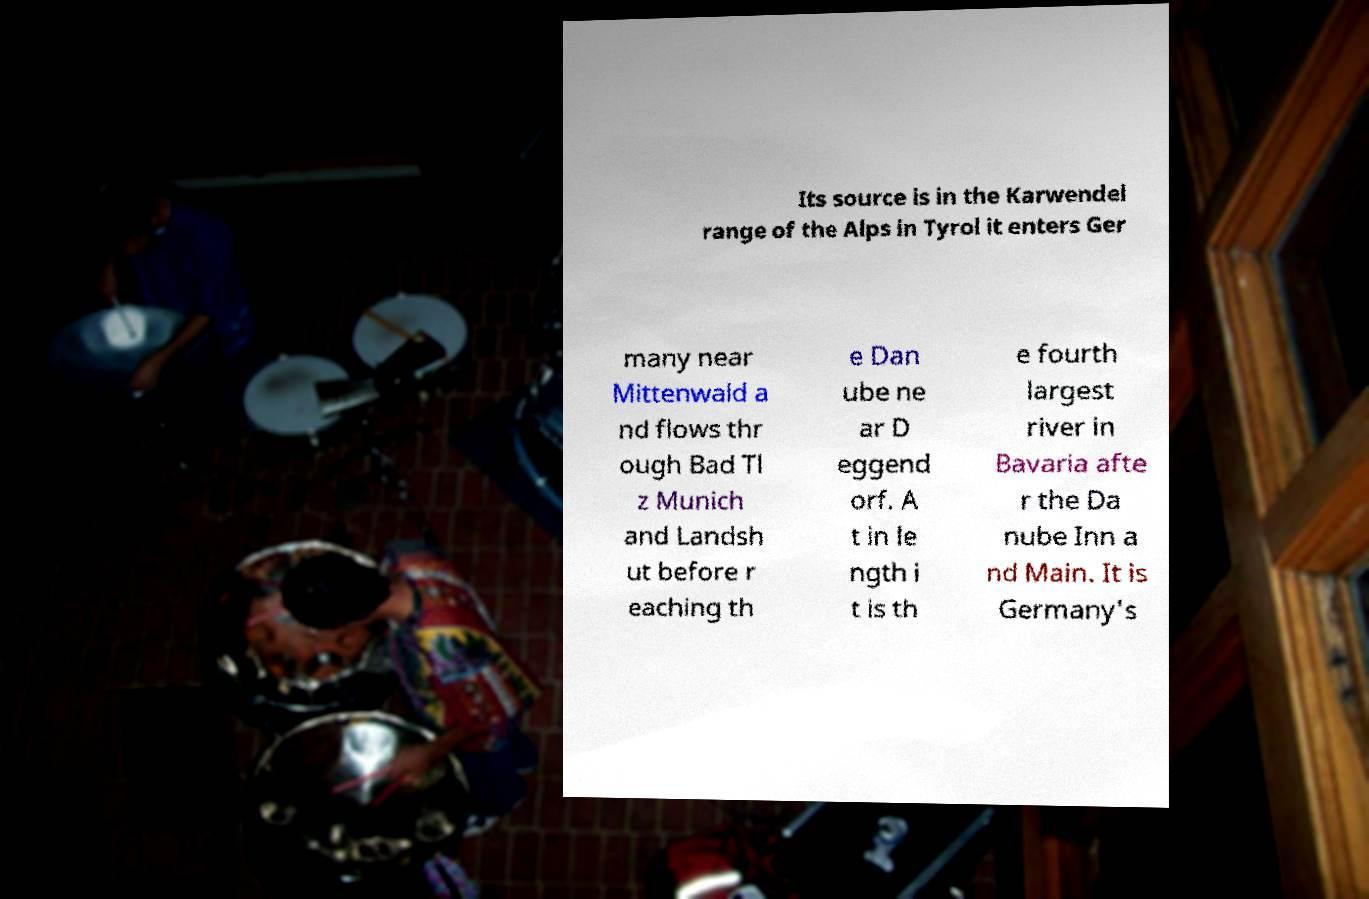Could you assist in decoding the text presented in this image and type it out clearly? Its source is in the Karwendel range of the Alps in Tyrol it enters Ger many near Mittenwald a nd flows thr ough Bad Tl z Munich and Landsh ut before r eaching th e Dan ube ne ar D eggend orf. A t in le ngth i t is th e fourth largest river in Bavaria afte r the Da nube Inn a nd Main. It is Germany's 